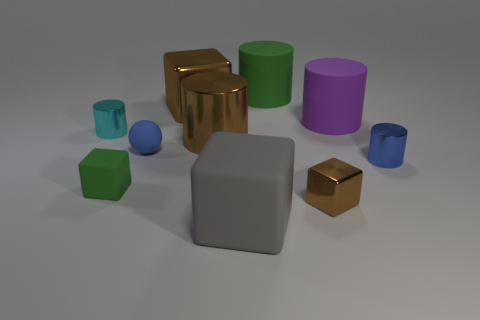Subtract 3 cubes. How many cubes are left? 1 Subtract all small matte blocks. Subtract all gray balls. How many objects are left? 9 Add 9 brown shiny cylinders. How many brown shiny cylinders are left? 10 Add 2 tiny yellow spheres. How many tiny yellow spheres exist? 2 Subtract all gray blocks. How many blocks are left? 3 Subtract all blue shiny cylinders. How many cylinders are left? 4 Subtract 0 purple cubes. How many objects are left? 10 Subtract all spheres. How many objects are left? 9 Subtract all yellow cylinders. Subtract all red spheres. How many cylinders are left? 5 Subtract all red spheres. How many red cylinders are left? 0 